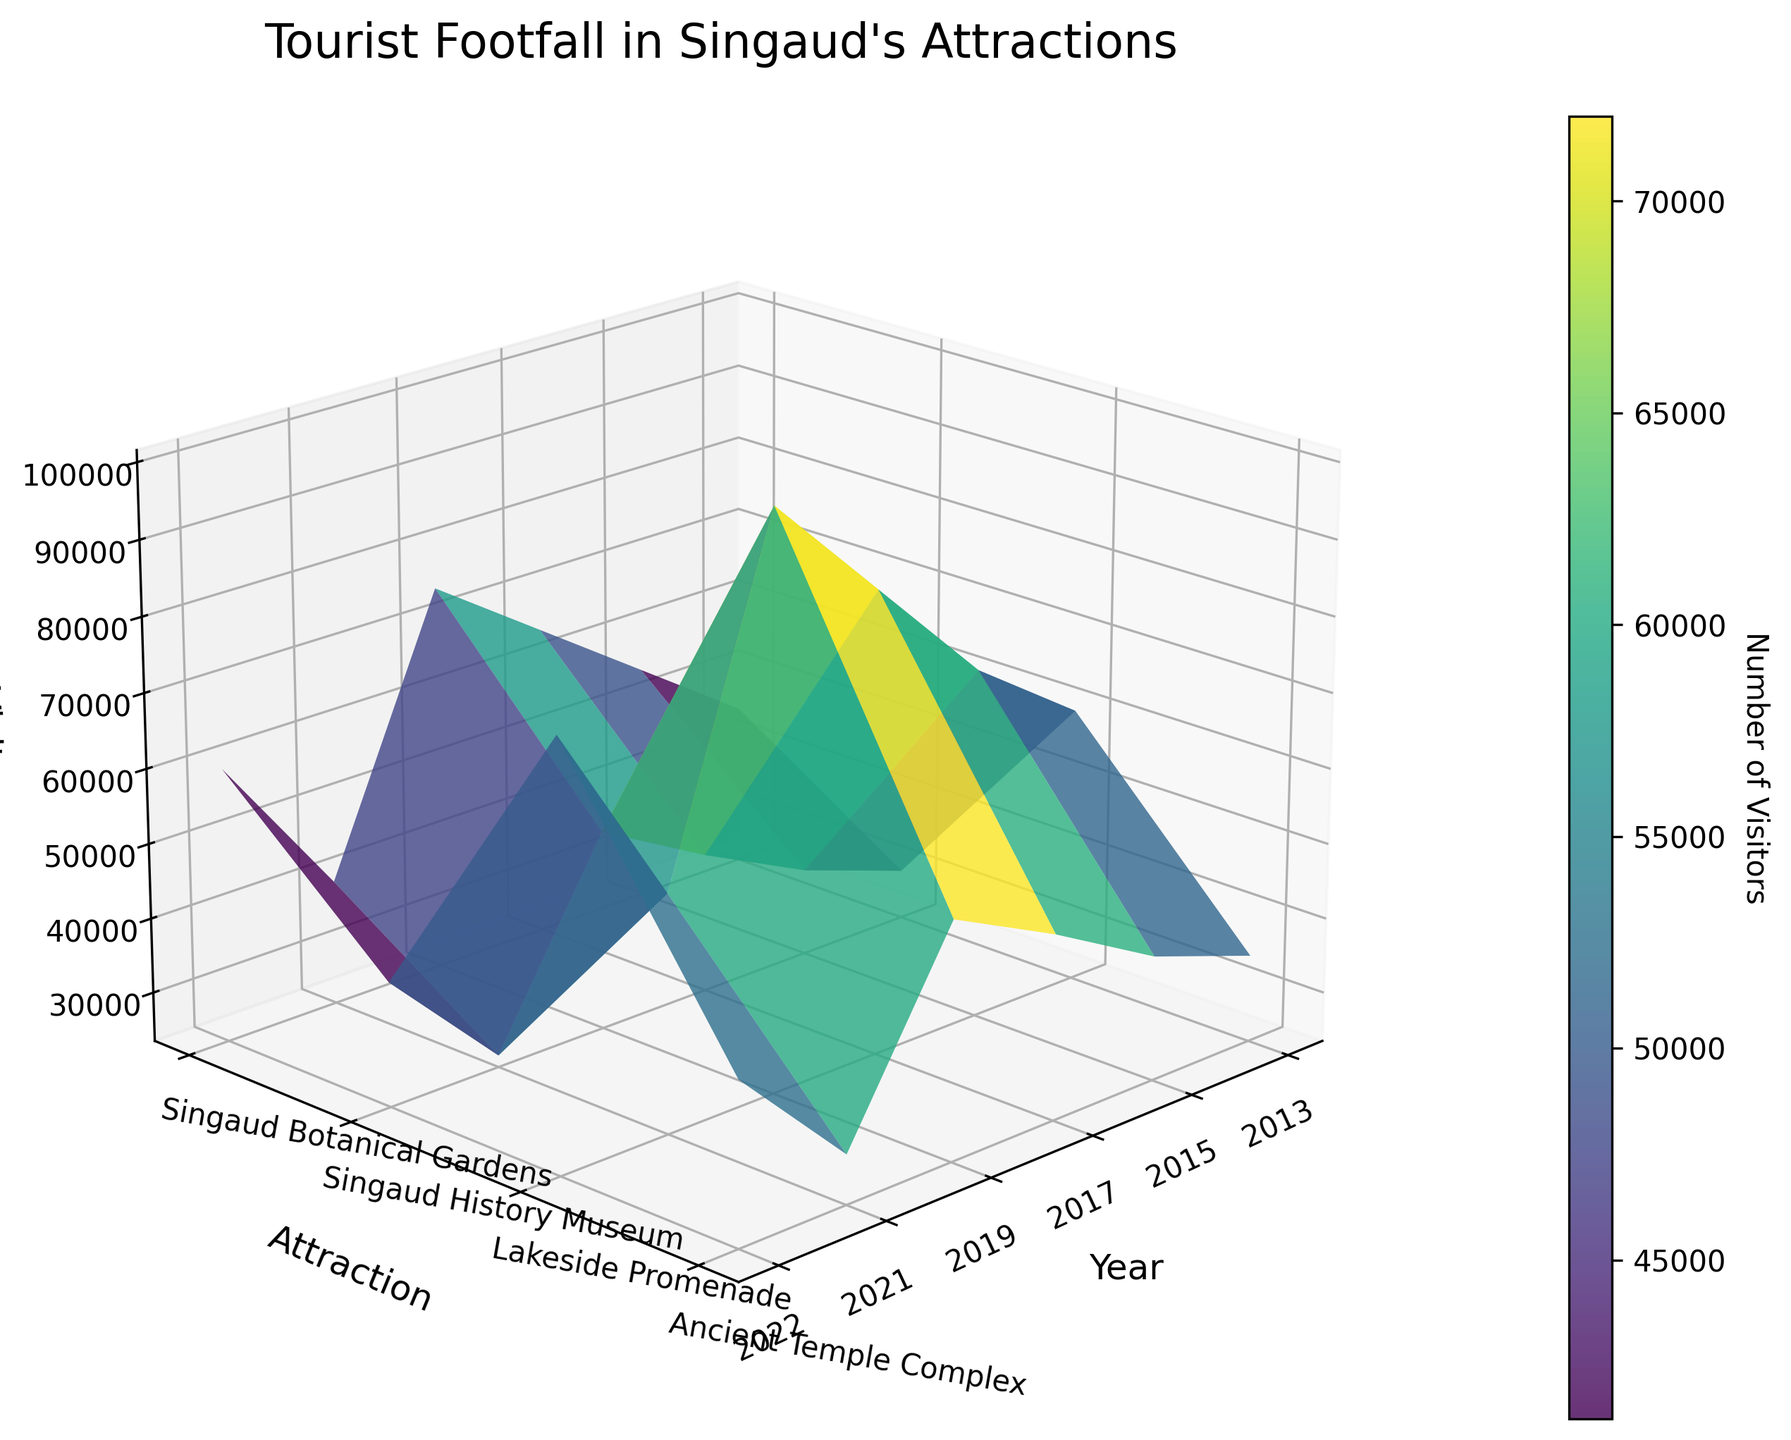Which attraction had the highest number of visitors in 2019? Look at the 2019 ticks on the x-axis and find the peak in the z-axis values among the attractions labeled on the y-axis. The highest z-value corresponds to the Lakeside Promenade.
Answer: Lakeside Promenade What was the visitor count for the Singaud Botanical Gardens in 2021? Find the intersection of the year 2021 on the x-axis and the Singaud Botanical Gardens on the y-axis, then read off the z-axis value at that point.
Answer: 40,000 Which year saw the highest footfall for the Lakeside Promenade? Identify the Lakeside Promenade on the y-axis, then find the highest point along its trajectory on the z-axis to determine the corresponding year on the x-axis.
Answer: 2019 How did the visitor count for the Singaud History Museum change from 2015 to 2017? Locate the Singaud History Museum on the y-axis, then compare the z-axis values at the 2015 and 2017 ticks on the x-axis. Calculate the difference.
Answer: Increased by 7,000 Which attraction had the least visitors in 2013? Check the 2013 tick on the x-axis and compare the z-axis values of all attractions. The lowest z-value corresponds to the Singaud History Museum.
Answer: Singaud History Museum What was the average visitor count for the Ancient Temple Complex from 2013 to 2019? Find the Ancient Temple Complex on the y-axis, then read off the z-axis values for the years 2013, 2015, 2017, and 2019. Sum these values and divide by 4.
Answer: 44,250 Did any attraction experience a decline in visitors between 2019 and 2021? Compare the z-axis values for each attraction between the years 2019 and 2021 by following their respective trajectories. Note which ones show a decrease.
Answer: Yes What is the difference in visitors between the highest and lowest attraction in 2022? Identify the highest and lowest z-axis points for 2022 on the x-axis, then subtract the smallest value from the largest.
Answer: 40,000 Which attraction shows the most consistent increase in visitors over the years (2013-2019)? Follow the trajectory of each attraction on the y-axis from 2013 to 2019 and observe which one shows a steady upward slope on the z-axis.
Answer: Singaud Botanical Gardens Between which two years did the Singaud History Museum see its largest increase in visitors? Track the Singaud History Museum on the y-axis and compare successive z-axis values to determine the largest increase.
Answer: 2017-2019 